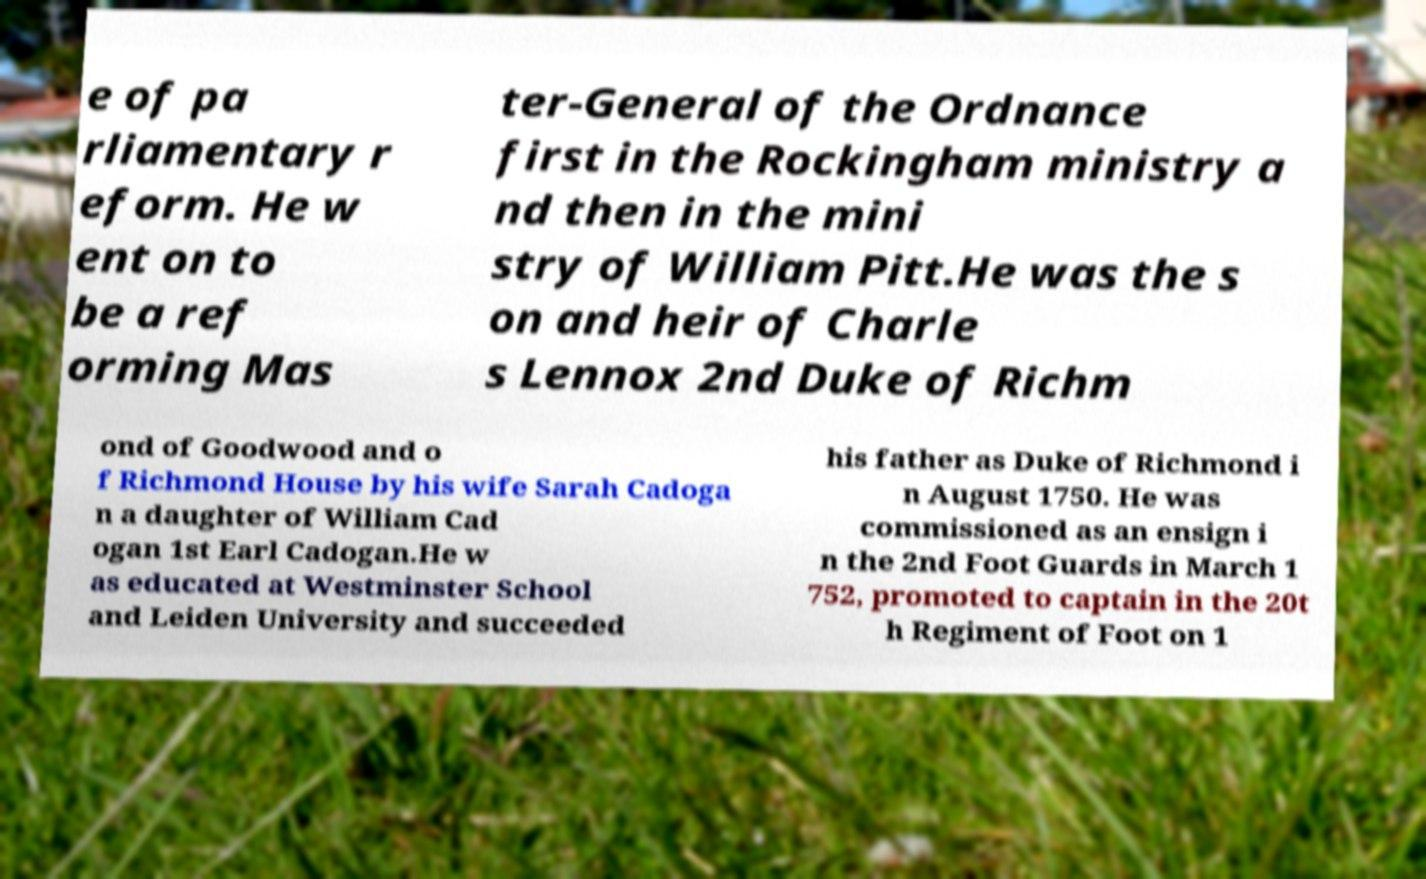Please identify and transcribe the text found in this image. e of pa rliamentary r eform. He w ent on to be a ref orming Mas ter-General of the Ordnance first in the Rockingham ministry a nd then in the mini stry of William Pitt.He was the s on and heir of Charle s Lennox 2nd Duke of Richm ond of Goodwood and o f Richmond House by his wife Sarah Cadoga n a daughter of William Cad ogan 1st Earl Cadogan.He w as educated at Westminster School and Leiden University and succeeded his father as Duke of Richmond i n August 1750. He was commissioned as an ensign i n the 2nd Foot Guards in March 1 752, promoted to captain in the 20t h Regiment of Foot on 1 